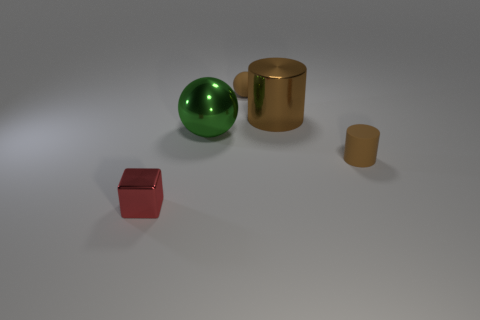Are the tiny sphere and the green sphere made of the same material?
Give a very brief answer. No. Is there a small brown cylinder that has the same material as the small sphere?
Your response must be concise. Yes. What is the color of the metallic ball?
Keep it short and to the point. Green. How big is the matte thing in front of the matte sphere?
Offer a very short reply. Small. What number of large balls have the same color as the metal block?
Ensure brevity in your answer.  0. Is there a small brown object behind the big object behind the large green metallic ball?
Provide a succinct answer. Yes. Do the large thing to the right of the small ball and the small thing on the left side of the tiny brown sphere have the same color?
Ensure brevity in your answer.  No. What color is the rubber cylinder that is the same size as the red shiny block?
Give a very brief answer. Brown. Are there an equal number of small brown objects that are on the right side of the large metallic cylinder and matte spheres to the right of the metal cube?
Ensure brevity in your answer.  Yes. The small cube that is on the left side of the small matte thing on the left side of the large cylinder is made of what material?
Your answer should be compact. Metal. 